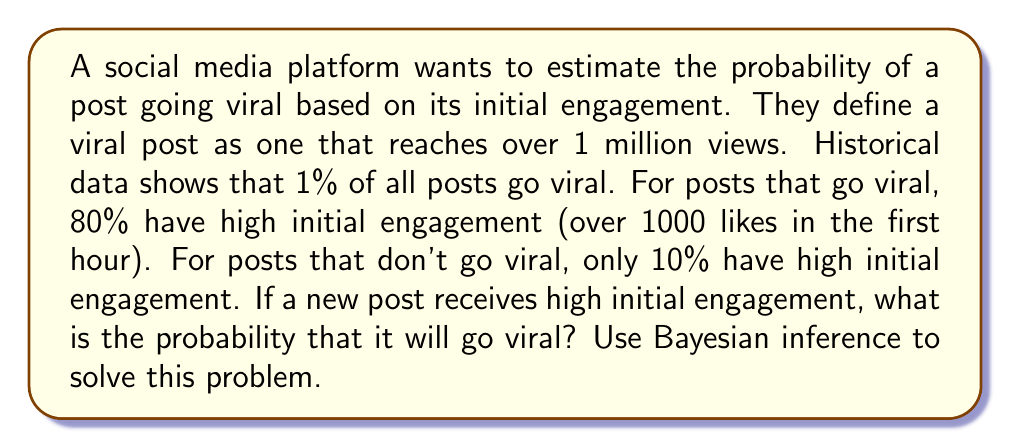Show me your answer to this math problem. Let's approach this problem using Bayes' theorem. We'll define the following events:

V: The post goes viral (reaches over 1 million views)
H: The post has high initial engagement (over 1000 likes in the first hour)

We're given the following probabilities:

$P(V) = 0.01$ (1% of all posts go viral)
$P(H|V) = 0.80$ (80% of viral posts have high initial engagement)
$P(H|\neg V) = 0.10$ (10% of non-viral posts have high initial engagement)

We want to find $P(V|H)$, the probability that a post goes viral given that it has high initial engagement.

Bayes' theorem states:

$$P(V|H) = \frac{P(H|V) \cdot P(V)}{P(H)}$$

We need to calculate $P(H)$, which we can do using the law of total probability:

$$P(H) = P(H|V) \cdot P(V) + P(H|\neg V) \cdot P(\neg V)$$

$P(\neg V) = 1 - P(V) = 1 - 0.01 = 0.99$

Now, let's calculate $P(H)$:

$$\begin{align}
P(H) &= 0.80 \cdot 0.01 + 0.10 \cdot 0.99 \\
&= 0.008 + 0.099 \\
&= 0.107
\end{align}$$

Now we can apply Bayes' theorem:

$$\begin{align}
P(V|H) &= \frac{P(H|V) \cdot P(V)}{P(H)} \\
&= \frac{0.80 \cdot 0.01}{0.107} \\
&= \frac{0.008}{0.107} \\
&\approx 0.0748
\end{align}$$

Therefore, the probability that a post will go viral given that it has high initial engagement is approximately 0.0748 or 7.48%.
Answer: $P(V|H) \approx 0.0748$ or 7.48% 